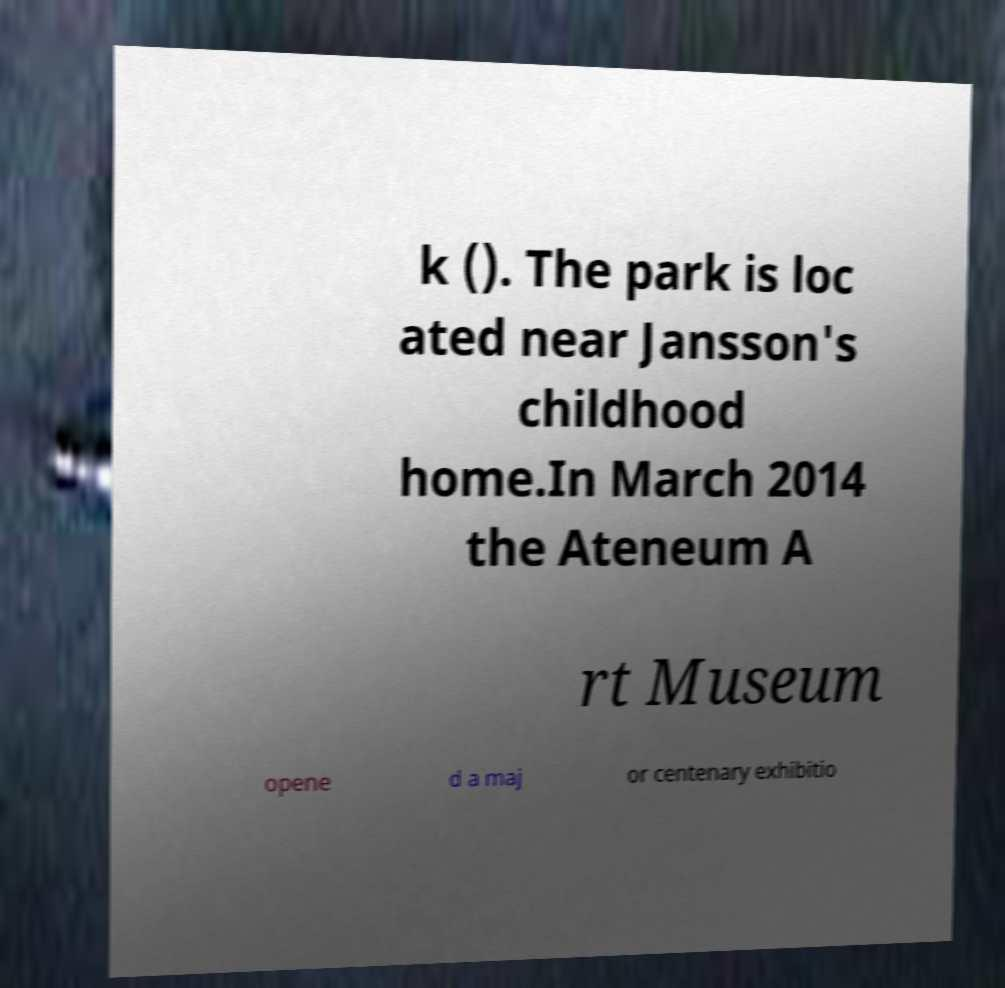What messages or text are displayed in this image? I need them in a readable, typed format. k (). The park is loc ated near Jansson's childhood home.In March 2014 the Ateneum A rt Museum opene d a maj or centenary exhibitio 